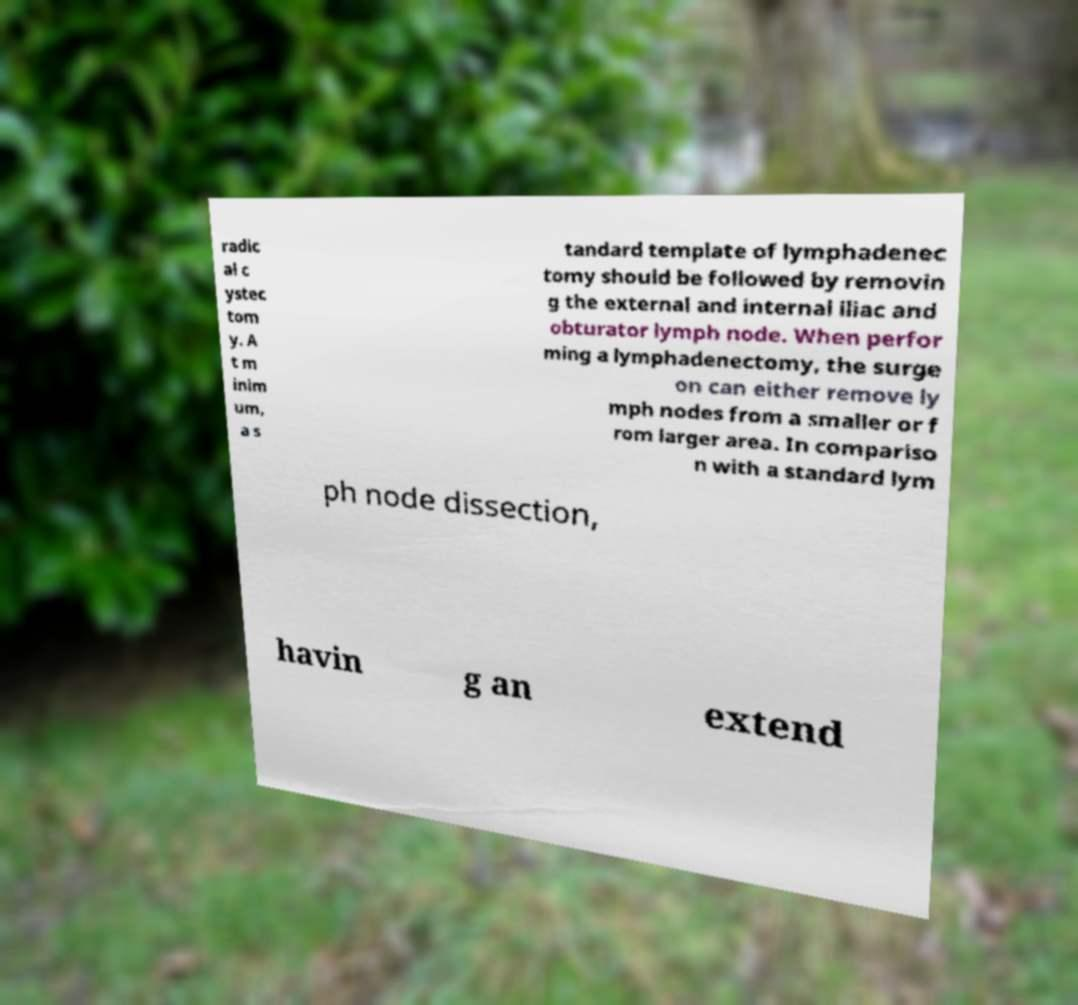What messages or text are displayed in this image? I need them in a readable, typed format. radic al c ystec tom y. A t m inim um, a s tandard template of lymphadenec tomy should be followed by removin g the external and internal iliac and obturator lymph node. When perfor ming a lymphadenectomy, the surge on can either remove ly mph nodes from a smaller or f rom larger area. In compariso n with a standard lym ph node dissection, havin g an extend 